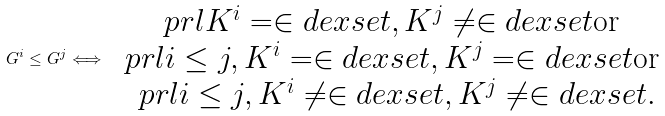<formula> <loc_0><loc_0><loc_500><loc_500>G ^ { i } \leq G ^ { j } \Longleftrightarrow \begin{array} { c } \ p r l { K ^ { i } = \in d e x s e t , K ^ { j } \neq \in d e x s e t } \text {or } \\ \ p r l { i \leq j , K ^ { i } = \in d e x s e t , K ^ { j } = \in d e x s e t } \text {or } \\ \ p r l { i \leq j , K ^ { i } \neq \in d e x s e t , K ^ { j } \neq \in d e x s e t } . \end{array}</formula> 